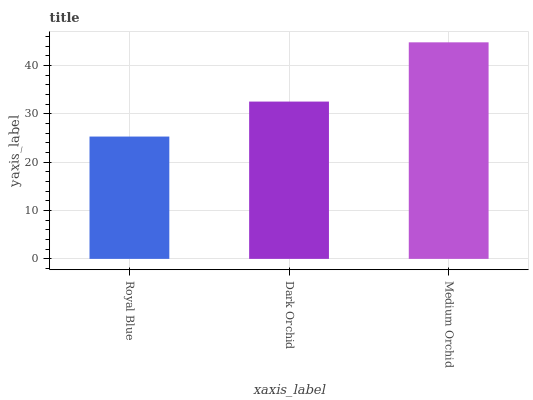Is Royal Blue the minimum?
Answer yes or no. Yes. Is Medium Orchid the maximum?
Answer yes or no. Yes. Is Dark Orchid the minimum?
Answer yes or no. No. Is Dark Orchid the maximum?
Answer yes or no. No. Is Dark Orchid greater than Royal Blue?
Answer yes or no. Yes. Is Royal Blue less than Dark Orchid?
Answer yes or no. Yes. Is Royal Blue greater than Dark Orchid?
Answer yes or no. No. Is Dark Orchid less than Royal Blue?
Answer yes or no. No. Is Dark Orchid the high median?
Answer yes or no. Yes. Is Dark Orchid the low median?
Answer yes or no. Yes. Is Royal Blue the high median?
Answer yes or no. No. Is Medium Orchid the low median?
Answer yes or no. No. 